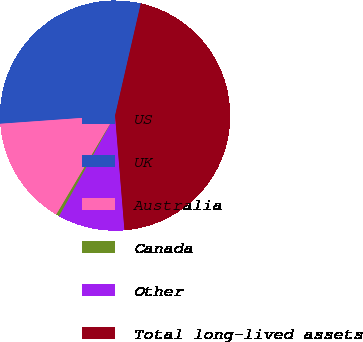<chart> <loc_0><loc_0><loc_500><loc_500><pie_chart><fcel>US<fcel>UK<fcel>Australia<fcel>Canada<fcel>Other<fcel>Total long-lived assets<nl><fcel>24.81%<fcel>4.92%<fcel>15.34%<fcel>0.45%<fcel>9.38%<fcel>45.11%<nl></chart> 